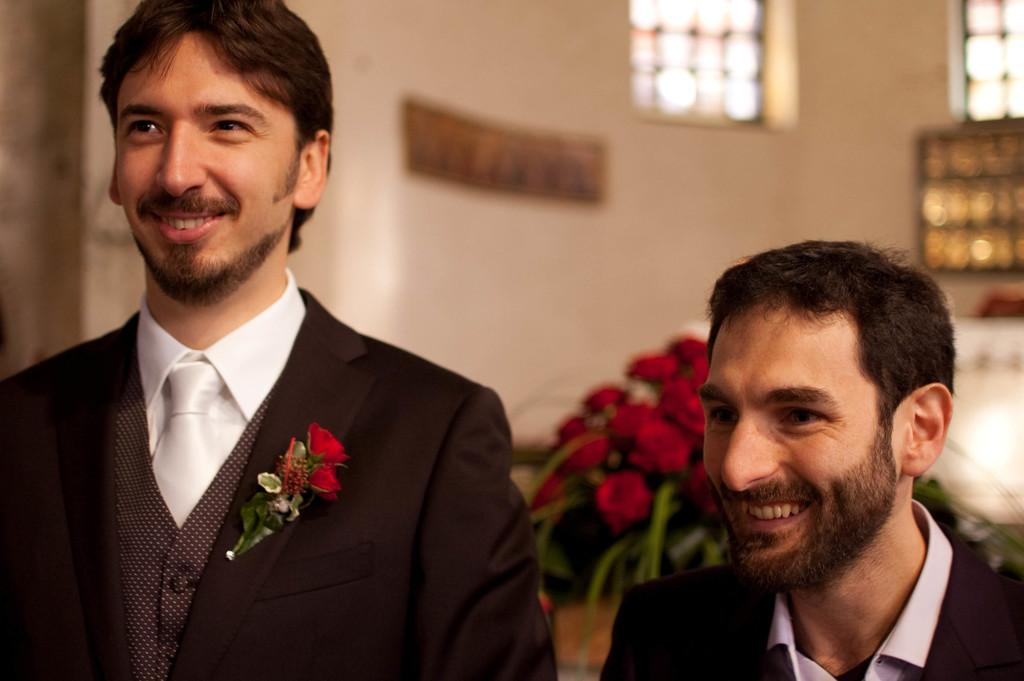How many people are in the image? There are two men in the image. What can be seen besides the two men? There is a bouquet and an object placed on a surface in the image. What is the background of the image like? There is a wall and windows in the image. What type of prose is being recited by the men in the image? There is no indication in the image that the men are reciting any prose, so it cannot be determined from the picture. 